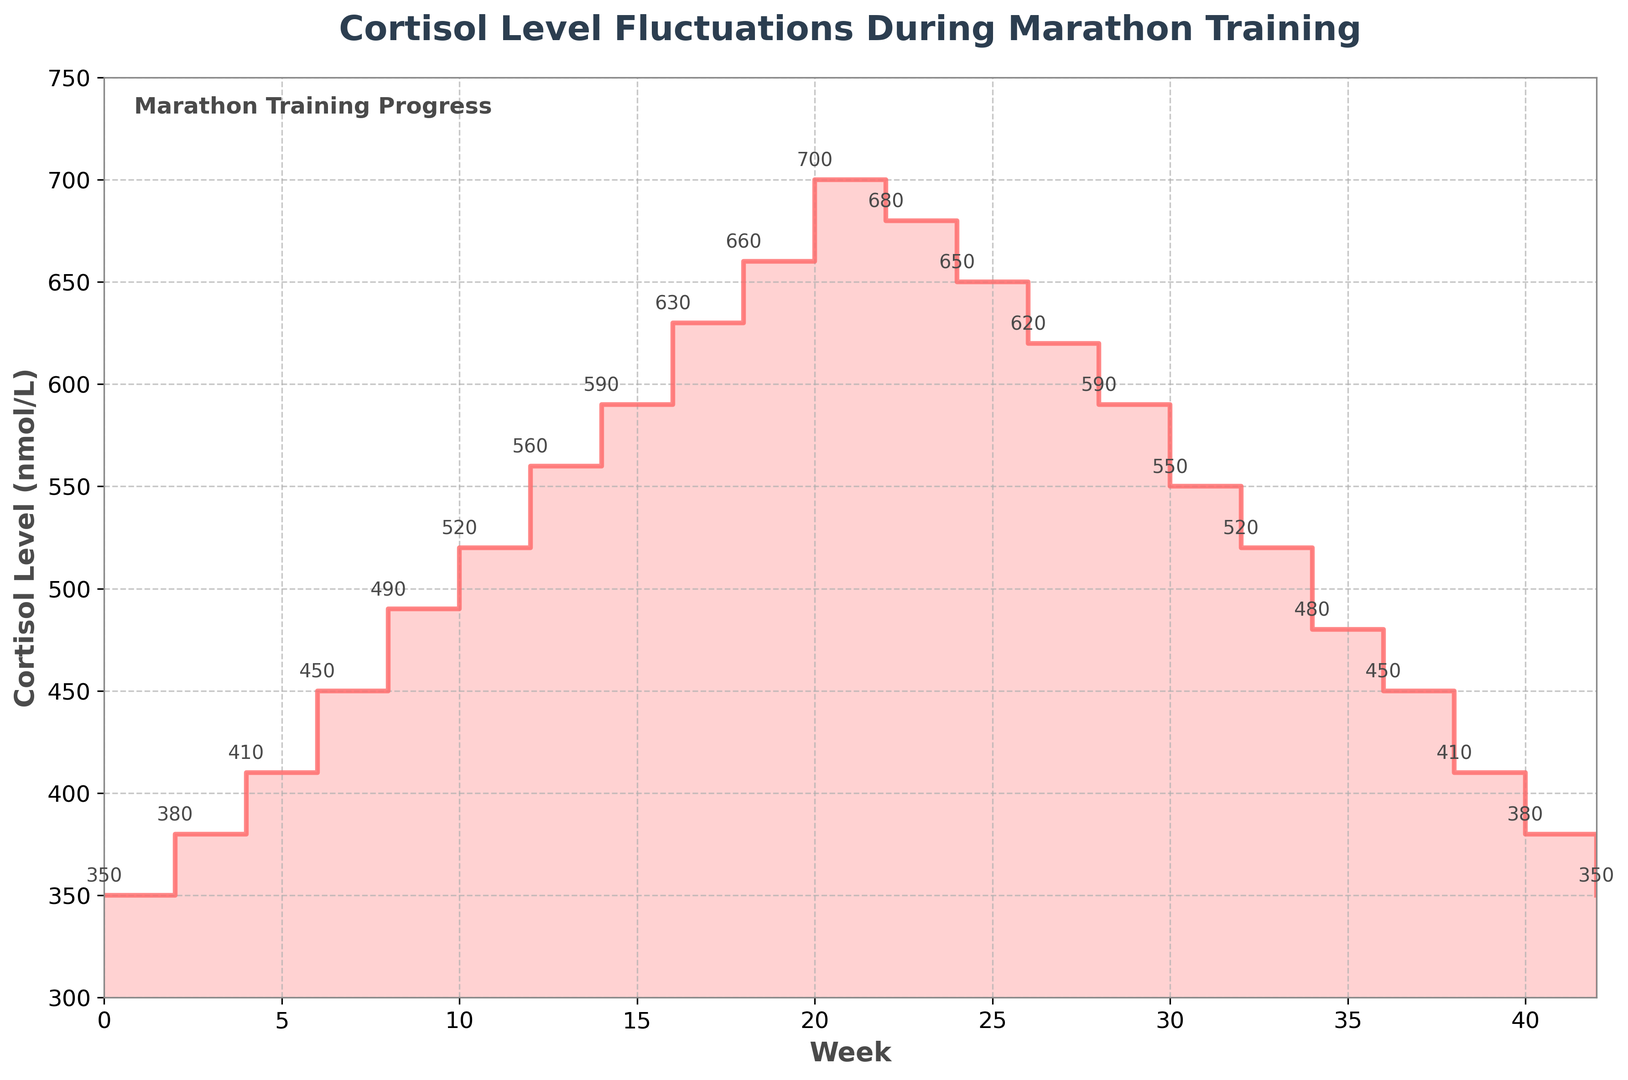What's the highest cortisol level recorded during the training cycle? The figure shows the cortisol levels at different weeks. The highest cortisol level is recorded at Week 20, reaching 700 nmol/L.
Answer: 700 nmol/L Is the cortisol level at Week 26 higher than Week 0? By how much? Week 26 has a cortisol level of 620 nmol/L, while Week 0 has 350 nmol/L. The difference is 620 - 350 = 270 nmol/L.
Answer: 270 nmol/L What is the average cortisol level between Week 10 and Week 20? The cortisol levels at weeks 10, 12, 14, 16, 18, and 20 are 520, 560, 590, 630, 660, and 700 respectively. The average is calculated as (520 + 560 + 590 + 630 + 660 + 700) / 6 = 610 nmol/L.
Answer: 610 nmol/L Between which weeks does the cortisol level first reach 600 nmol/L? The cortisol level reaches 590 nmol/L at Week 14 and exceeds 600 nmol/L at Week 16 where it is recorded as 630 nmol/L. Therefore, it first reaches between Week 14 and Week 16.
Answer: Between Week 14 and Week 16 How does the cortisol level at the end of the training cycle compare to the beginning? The cortisol level at Week 42 (end) is 350 nmol/L. At Week 0 (beginning), it is also 350 nmol/L. The levels are the same at both points.
Answer: Same What's the overall trend of the cortisol level from Week 0 to Week 42? At first, the cortisol level rises steadily until Week 20 where it peaks at 700 nmol/L. After Week 20, it gradually declines back to the initial level of 350 nmol/L by Week 42.
Answer: Rise and fall Is there any week where the cortisol level decreased from the previous week? No, in the given data, the cortisol level only increases from Week 0 to Week 20 and then gradually decreases but doesn’t show a week-on-week decrease during the incline.
Answer: No If the average cortisol level is considered high above 500 nmol/L, how many weeks show high cortisol levels? The weeks with cortisol levels above 500 nmol/L are Weeks 10 to 28. The total number of weeks in this range is 10.
Answer: 10 weeks 